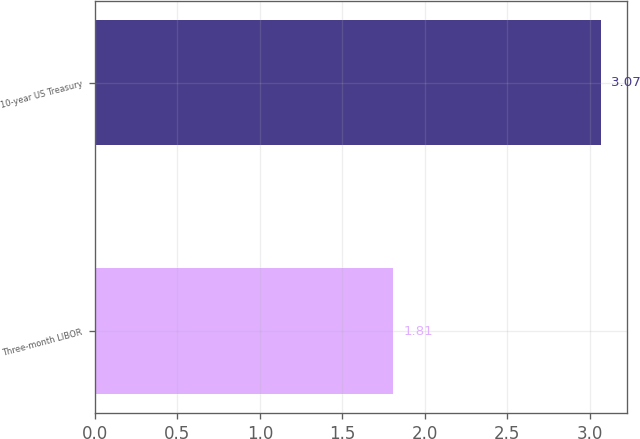Convert chart. <chart><loc_0><loc_0><loc_500><loc_500><bar_chart><fcel>Three-month LIBOR<fcel>10-year US Treasury<nl><fcel>1.81<fcel>3.07<nl></chart> 